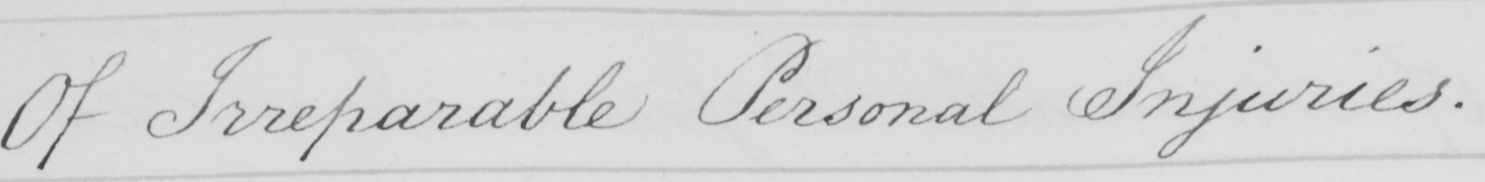Transcribe the text shown in this historical manuscript line. Of Irreparable Personal Injuries . 